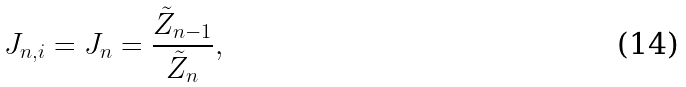<formula> <loc_0><loc_0><loc_500><loc_500>J _ { n , i } = J _ { n } = \frac { \tilde { Z } _ { n - 1 } } { \tilde { Z } _ { n } } ,</formula> 